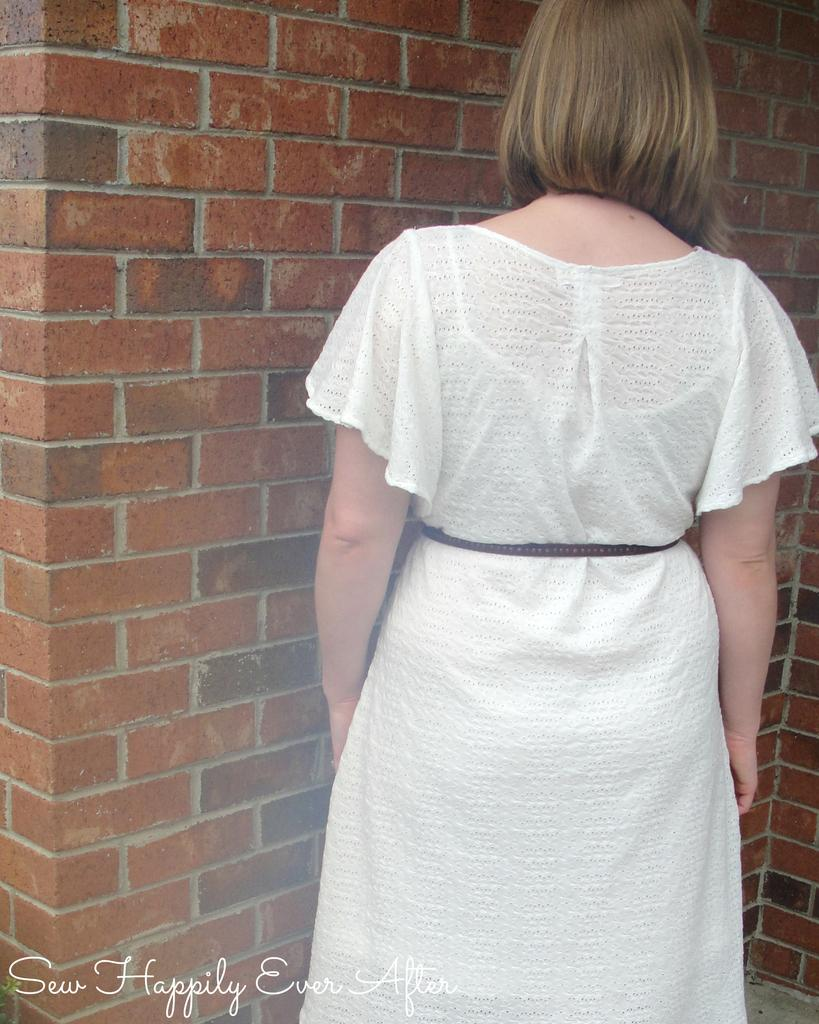Who is present in the image? There is a woman in the image. What is the woman wearing? The woman is wearing a white dress. What type of structure can be seen in the background? There is a brick wall in the image. Is there any text or logo visible in the image? Yes, there is a watermark in the image. What type of vegetable is the woman holding in the image? There is no vegetable present in the image; the woman is not holding anything. What is the plot of the story being told in the image? The image does not depict a story or plot; it is a static representation of a woman standing in front of a brick wall. 